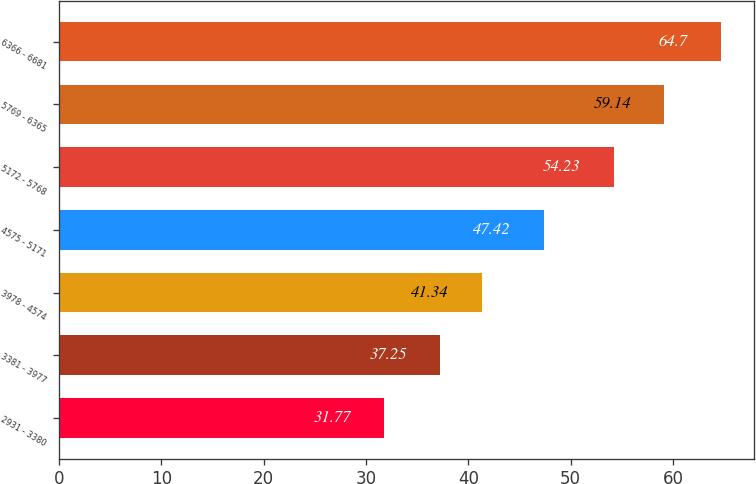<chart> <loc_0><loc_0><loc_500><loc_500><bar_chart><fcel>2931 - 3380<fcel>3381 - 3977<fcel>3978 - 4574<fcel>4575 - 5171<fcel>5172 - 5768<fcel>5769 - 6365<fcel>6366 - 6681<nl><fcel>31.77<fcel>37.25<fcel>41.34<fcel>47.42<fcel>54.23<fcel>59.14<fcel>64.7<nl></chart> 